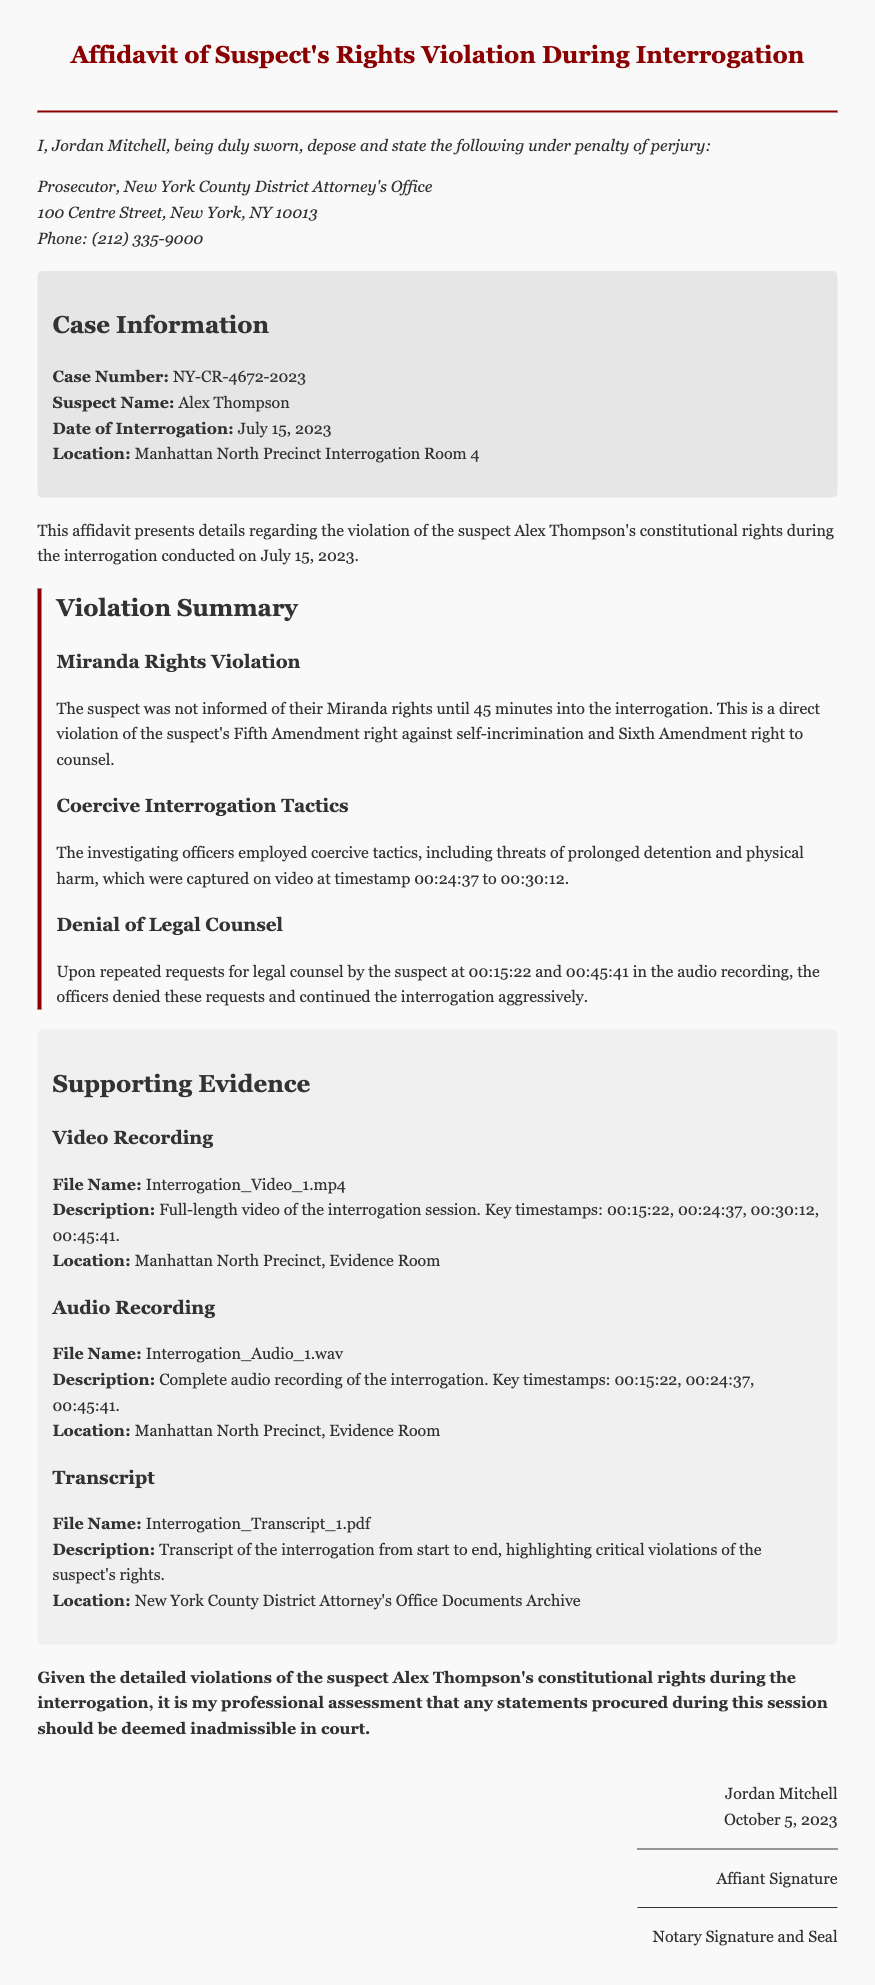What is the name of the suspect? The document explicitly states that the suspect's name is Alex Thompson.
Answer: Alex Thompson What was the date of the interrogation? The document specifies that the interrogation took place on July 15, 2023.
Answer: July 15, 2023 What rights were violated according to the affidavit? The affidavit lists violations of the Fifth Amendment right against self-incrimination and the Sixth Amendment right to counsel.
Answer: Fifth and Sixth Amendments What coercive tactics were mentioned during the interrogation? The affidavit describes threats of prolonged detention and physical harm as coercive tactics used by officers.
Answer: Threats of prolonged detention and physical harm How long into the interrogation were Miranda rights provided? The affidavit states that Miranda rights were provided 45 minutes into the interrogation.
Answer: 45 minutes What evidence types are listed in the affidavit? The affidavit lists video recording, audio recording, and transcript as types of supporting evidence.
Answer: Video recording, audio recording, transcript What is the conclusion drawn in the affidavit? The affidavit concludes that any statements procured during this session should be deemed inadmissible in court.
Answer: Statements deemed inadmissible What is the file name of the video recording? The affidavit specifies that the video recording is named Interrogation_Video_1.mp4.
Answer: Interrogation_Video_1.mp4 Who authored the affidavit? The document mentions that the affidavit was authored by Jordan Mitchell.
Answer: Jordan Mitchell 